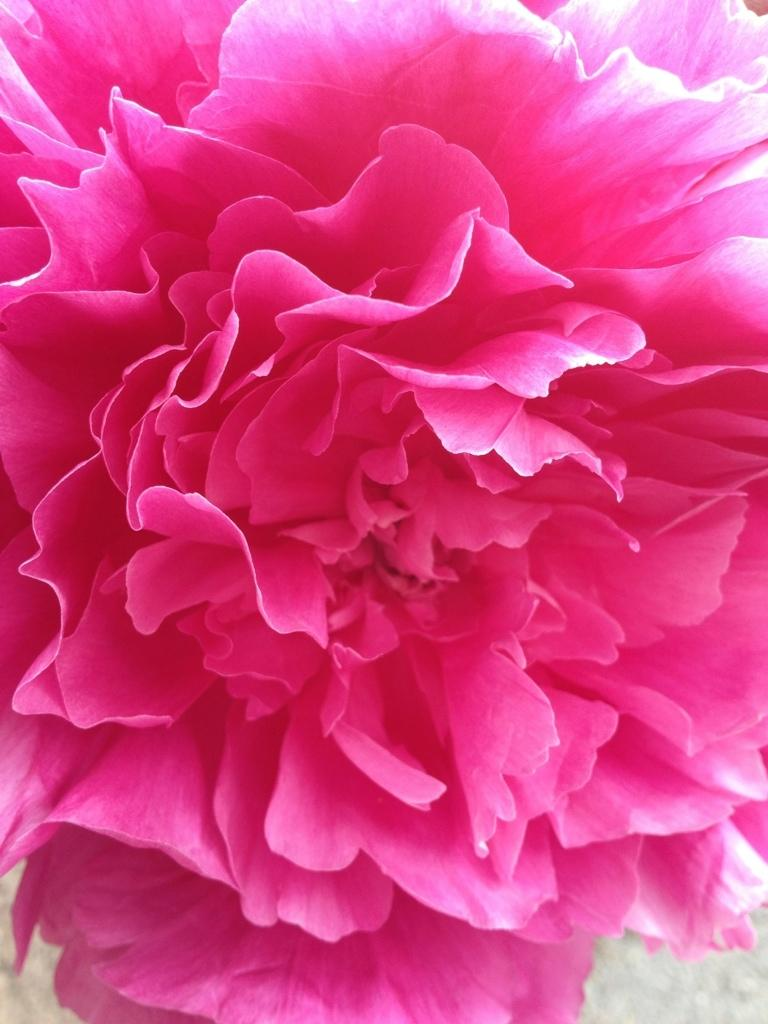What is the main subject of the image? There is a flower in the image. Can you describe the color of the flower? The flower is pink in color. What is visible beneath the flower in the image? There is a ground visible in the image. What type of coat is the owner wearing in the image? There is no owner or coat present in the image; it only features a pink flower. 